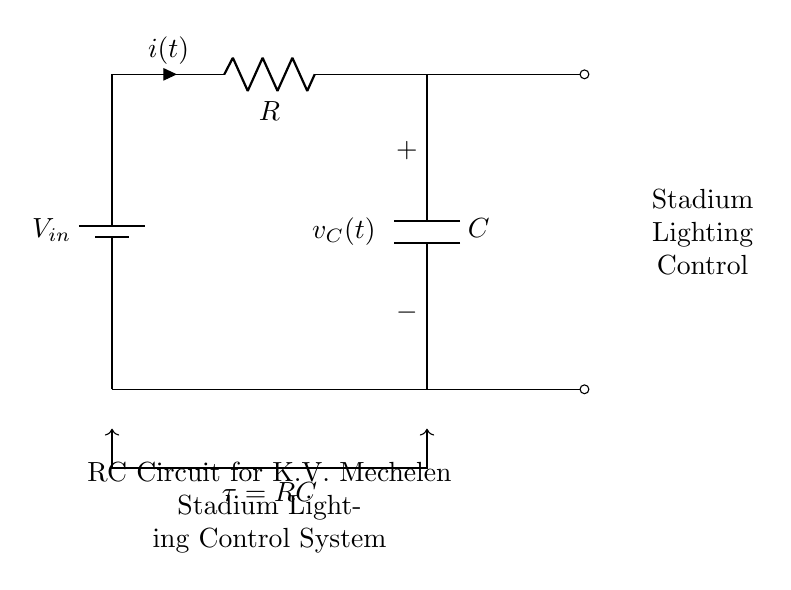What are the components of this circuit? The circuit contains a battery, a resistor, and a capacitor. These components are depicted in the diagram, with their respective symbols.
Answer: battery, resistor, capacitor What is the role of the capacitor in this circuit? The capacitor stores energy and releases it over time, affecting the charging and discharging phases. Its behavior is critical in controlling the timing for the stadium lighting.
Answer: timing control What is the time constant of this RC circuit? The time constant is given by the formula \( \tau = RC \), indicating how quickly the circuit responds to changes in voltage. This relationship is directly noted in the diagram.
Answer: RC How does current flow in this circuit when the switch is closed? When the switch is closed, current flows from the battery through the resistor and into the capacitor. This creates a charging effect, increasing the voltage across the capacitor over time.
Answer: from battery to capacitor What happens when the capacitor is fully charged? Once the capacitor is fully charged, the current flow decreases to zero, meaning no further charge accumulation occurs. This stabilizes the voltage across the capacitor, which can then control the lighting.
Answer: current stops, voltage stabilizes What is the voltage across the capacitor denoted as in the circuit? The voltage across the capacitor is labeled in the diagram as \( v_C(t) \), depicting the time-dependent voltage change across the capacitor during its charge and discharge cycles.
Answer: v_C(t) 